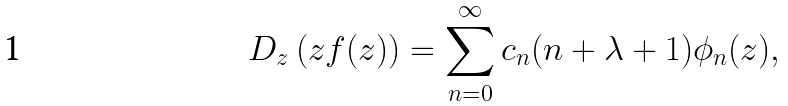Convert formula to latex. <formula><loc_0><loc_0><loc_500><loc_500>D _ { z } \left ( z f ( z ) \right ) = \sum _ { n = 0 } ^ { \infty } c _ { n } ( n + \lambda + 1 ) \phi _ { n } ( z ) ,</formula> 